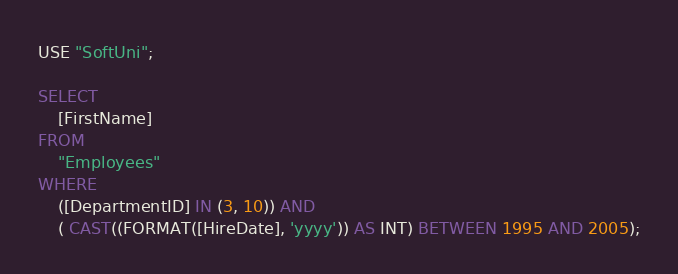Convert code to text. <code><loc_0><loc_0><loc_500><loc_500><_SQL_>USE "SoftUni";

SELECT
	[FirstName]
FROM 
	"Employees"
WHERE
	([DepartmentID] IN (3, 10)) AND 
	( CAST((FORMAT([HireDate], 'yyyy')) AS INT) BETWEEN 1995 AND 2005);</code> 